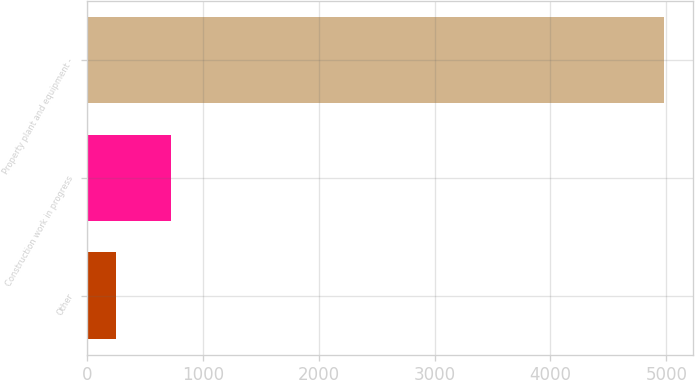Convert chart. <chart><loc_0><loc_0><loc_500><loc_500><bar_chart><fcel>Other<fcel>Construction work in progress<fcel>Property plant and equipment -<nl><fcel>250<fcel>723.1<fcel>4981<nl></chart> 